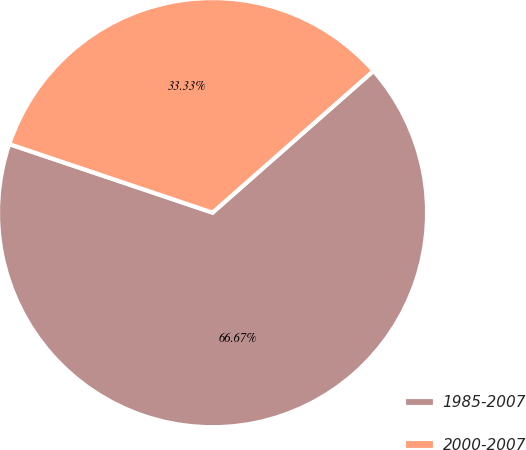Convert chart. <chart><loc_0><loc_0><loc_500><loc_500><pie_chart><fcel>1985-2007<fcel>2000-2007<nl><fcel>66.67%<fcel>33.33%<nl></chart> 